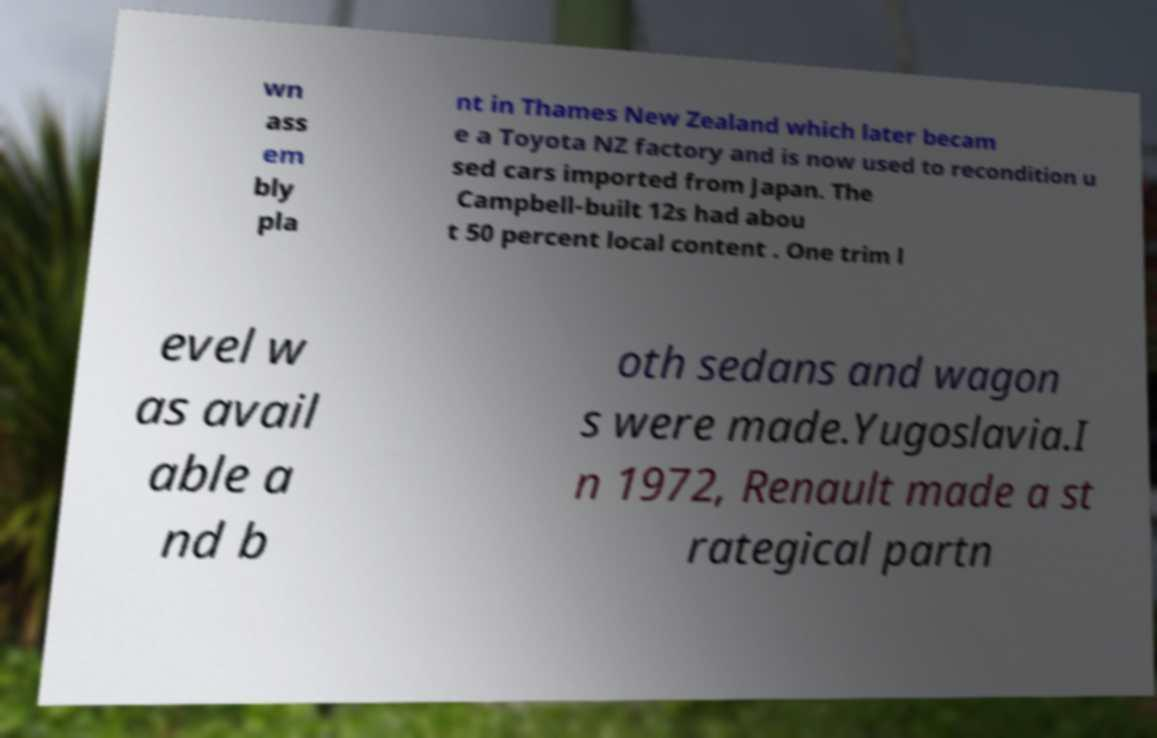For documentation purposes, I need the text within this image transcribed. Could you provide that? wn ass em bly pla nt in Thames New Zealand which later becam e a Toyota NZ factory and is now used to recondition u sed cars imported from Japan. The Campbell-built 12s had abou t 50 percent local content . One trim l evel w as avail able a nd b oth sedans and wagon s were made.Yugoslavia.I n 1972, Renault made a st rategical partn 